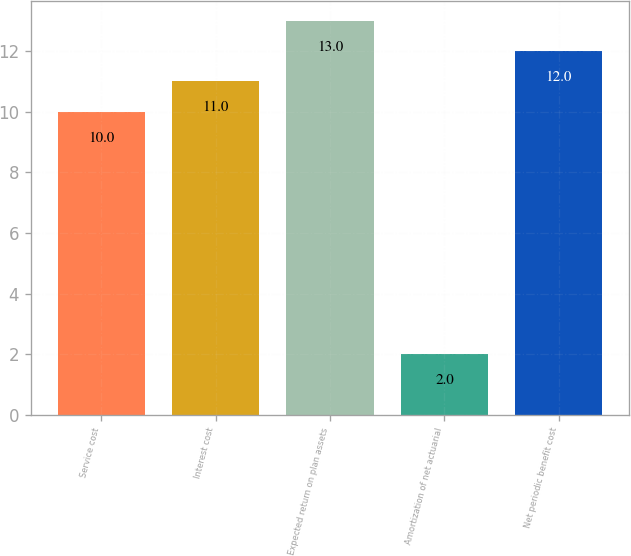<chart> <loc_0><loc_0><loc_500><loc_500><bar_chart><fcel>Service cost<fcel>Interest cost<fcel>Expected return on plan assets<fcel>Amortization of net actuarial<fcel>Net periodic benefit cost<nl><fcel>10<fcel>11<fcel>13<fcel>2<fcel>12<nl></chart> 